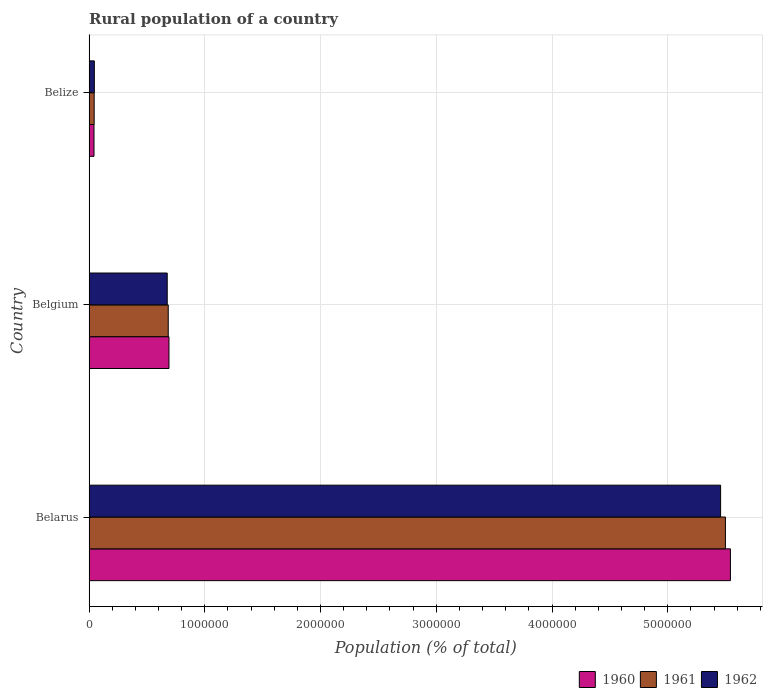How many different coloured bars are there?
Your answer should be compact. 3. Are the number of bars per tick equal to the number of legend labels?
Offer a terse response. Yes. How many bars are there on the 2nd tick from the top?
Make the answer very short. 3. What is the label of the 3rd group of bars from the top?
Give a very brief answer. Belarus. In how many cases, is the number of bars for a given country not equal to the number of legend labels?
Your response must be concise. 0. What is the rural population in 1962 in Belarus?
Your answer should be very brief. 5.46e+06. Across all countries, what is the maximum rural population in 1960?
Your answer should be compact. 5.54e+06. Across all countries, what is the minimum rural population in 1962?
Offer a very short reply. 4.54e+04. In which country was the rural population in 1961 maximum?
Offer a terse response. Belarus. In which country was the rural population in 1962 minimum?
Keep it short and to the point. Belize. What is the total rural population in 1960 in the graph?
Offer a very short reply. 6.27e+06. What is the difference between the rural population in 1961 in Belarus and that in Belgium?
Make the answer very short. 4.81e+06. What is the difference between the rural population in 1962 in Belize and the rural population in 1960 in Belgium?
Offer a terse response. -6.45e+05. What is the average rural population in 1961 per country?
Provide a short and direct response. 2.08e+06. What is the difference between the rural population in 1962 and rural population in 1961 in Belize?
Give a very brief answer. 1546. In how many countries, is the rural population in 1961 greater than 4000000 %?
Provide a short and direct response. 1. What is the ratio of the rural population in 1962 in Belarus to that in Belize?
Keep it short and to the point. 120.26. Is the rural population in 1961 in Belarus less than that in Belgium?
Offer a very short reply. No. What is the difference between the highest and the second highest rural population in 1960?
Give a very brief answer. 4.85e+06. What is the difference between the highest and the lowest rural population in 1960?
Offer a very short reply. 5.50e+06. Is the sum of the rural population in 1960 in Belarus and Belize greater than the maximum rural population in 1961 across all countries?
Ensure brevity in your answer.  Yes. What does the 2nd bar from the top in Belgium represents?
Your answer should be very brief. 1961. Is it the case that in every country, the sum of the rural population in 1961 and rural population in 1962 is greater than the rural population in 1960?
Provide a short and direct response. Yes. How many countries are there in the graph?
Your response must be concise. 3. Are the values on the major ticks of X-axis written in scientific E-notation?
Provide a succinct answer. No. Where does the legend appear in the graph?
Ensure brevity in your answer.  Bottom right. How are the legend labels stacked?
Provide a succinct answer. Horizontal. What is the title of the graph?
Keep it short and to the point. Rural population of a country. Does "2003" appear as one of the legend labels in the graph?
Provide a short and direct response. No. What is the label or title of the X-axis?
Keep it short and to the point. Population (% of total). What is the Population (% of total) in 1960 in Belarus?
Your response must be concise. 5.54e+06. What is the Population (% of total) in 1961 in Belarus?
Provide a succinct answer. 5.50e+06. What is the Population (% of total) in 1962 in Belarus?
Your response must be concise. 5.46e+06. What is the Population (% of total) in 1960 in Belgium?
Give a very brief answer. 6.90e+05. What is the Population (% of total) of 1961 in Belgium?
Offer a very short reply. 6.84e+05. What is the Population (% of total) in 1962 in Belgium?
Offer a terse response. 6.75e+05. What is the Population (% of total) in 1960 in Belize?
Provide a short and direct response. 4.23e+04. What is the Population (% of total) in 1961 in Belize?
Give a very brief answer. 4.38e+04. What is the Population (% of total) in 1962 in Belize?
Offer a terse response. 4.54e+04. Across all countries, what is the maximum Population (% of total) of 1960?
Provide a short and direct response. 5.54e+06. Across all countries, what is the maximum Population (% of total) of 1961?
Your answer should be very brief. 5.50e+06. Across all countries, what is the maximum Population (% of total) in 1962?
Offer a terse response. 5.46e+06. Across all countries, what is the minimum Population (% of total) of 1960?
Your answer should be very brief. 4.23e+04. Across all countries, what is the minimum Population (% of total) in 1961?
Your answer should be very brief. 4.38e+04. Across all countries, what is the minimum Population (% of total) of 1962?
Keep it short and to the point. 4.54e+04. What is the total Population (% of total) in 1960 in the graph?
Your response must be concise. 6.27e+06. What is the total Population (% of total) of 1961 in the graph?
Keep it short and to the point. 6.23e+06. What is the total Population (% of total) of 1962 in the graph?
Your answer should be very brief. 6.18e+06. What is the difference between the Population (% of total) in 1960 in Belarus and that in Belgium?
Your answer should be very brief. 4.85e+06. What is the difference between the Population (% of total) in 1961 in Belarus and that in Belgium?
Give a very brief answer. 4.81e+06. What is the difference between the Population (% of total) in 1962 in Belarus and that in Belgium?
Provide a short and direct response. 4.78e+06. What is the difference between the Population (% of total) in 1960 in Belarus and that in Belize?
Give a very brief answer. 5.50e+06. What is the difference between the Population (% of total) of 1961 in Belarus and that in Belize?
Keep it short and to the point. 5.45e+06. What is the difference between the Population (% of total) of 1962 in Belarus and that in Belize?
Ensure brevity in your answer.  5.41e+06. What is the difference between the Population (% of total) of 1960 in Belgium and that in Belize?
Provide a succinct answer. 6.48e+05. What is the difference between the Population (% of total) in 1961 in Belgium and that in Belize?
Your answer should be compact. 6.40e+05. What is the difference between the Population (% of total) of 1962 in Belgium and that in Belize?
Give a very brief answer. 6.30e+05. What is the difference between the Population (% of total) in 1960 in Belarus and the Population (% of total) in 1961 in Belgium?
Offer a terse response. 4.86e+06. What is the difference between the Population (% of total) in 1960 in Belarus and the Population (% of total) in 1962 in Belgium?
Provide a short and direct response. 4.87e+06. What is the difference between the Population (% of total) in 1961 in Belarus and the Population (% of total) in 1962 in Belgium?
Make the answer very short. 4.82e+06. What is the difference between the Population (% of total) in 1960 in Belarus and the Population (% of total) in 1961 in Belize?
Offer a terse response. 5.50e+06. What is the difference between the Population (% of total) in 1960 in Belarus and the Population (% of total) in 1962 in Belize?
Your answer should be compact. 5.50e+06. What is the difference between the Population (% of total) in 1961 in Belarus and the Population (% of total) in 1962 in Belize?
Offer a terse response. 5.45e+06. What is the difference between the Population (% of total) of 1960 in Belgium and the Population (% of total) of 1961 in Belize?
Ensure brevity in your answer.  6.46e+05. What is the difference between the Population (% of total) in 1960 in Belgium and the Population (% of total) in 1962 in Belize?
Provide a succinct answer. 6.45e+05. What is the difference between the Population (% of total) in 1961 in Belgium and the Population (% of total) in 1962 in Belize?
Keep it short and to the point. 6.38e+05. What is the average Population (% of total) in 1960 per country?
Ensure brevity in your answer.  2.09e+06. What is the average Population (% of total) in 1961 per country?
Your answer should be compact. 2.08e+06. What is the average Population (% of total) in 1962 per country?
Provide a succinct answer. 2.06e+06. What is the difference between the Population (% of total) of 1960 and Population (% of total) of 1961 in Belarus?
Keep it short and to the point. 4.32e+04. What is the difference between the Population (% of total) of 1960 and Population (% of total) of 1962 in Belarus?
Your response must be concise. 8.49e+04. What is the difference between the Population (% of total) in 1961 and Population (% of total) in 1962 in Belarus?
Ensure brevity in your answer.  4.16e+04. What is the difference between the Population (% of total) of 1960 and Population (% of total) of 1961 in Belgium?
Provide a succinct answer. 6336. What is the difference between the Population (% of total) of 1960 and Population (% of total) of 1962 in Belgium?
Keep it short and to the point. 1.51e+04. What is the difference between the Population (% of total) of 1961 and Population (% of total) of 1962 in Belgium?
Give a very brief answer. 8798. What is the difference between the Population (% of total) in 1960 and Population (% of total) in 1961 in Belize?
Your response must be concise. -1502. What is the difference between the Population (% of total) of 1960 and Population (% of total) of 1962 in Belize?
Provide a short and direct response. -3048. What is the difference between the Population (% of total) in 1961 and Population (% of total) in 1962 in Belize?
Offer a terse response. -1546. What is the ratio of the Population (% of total) of 1960 in Belarus to that in Belgium?
Offer a terse response. 8.03. What is the ratio of the Population (% of total) in 1961 in Belarus to that in Belgium?
Provide a succinct answer. 8.04. What is the ratio of the Population (% of total) in 1962 in Belarus to that in Belgium?
Ensure brevity in your answer.  8.08. What is the ratio of the Population (% of total) in 1960 in Belarus to that in Belize?
Your answer should be very brief. 130.93. What is the ratio of the Population (% of total) of 1961 in Belarus to that in Belize?
Give a very brief answer. 125.46. What is the ratio of the Population (% of total) in 1962 in Belarus to that in Belize?
Provide a short and direct response. 120.26. What is the ratio of the Population (% of total) of 1960 in Belgium to that in Belize?
Your response must be concise. 16.31. What is the ratio of the Population (% of total) in 1961 in Belgium to that in Belize?
Your answer should be compact. 15.6. What is the ratio of the Population (% of total) in 1962 in Belgium to that in Belize?
Provide a short and direct response. 14.88. What is the difference between the highest and the second highest Population (% of total) of 1960?
Offer a terse response. 4.85e+06. What is the difference between the highest and the second highest Population (% of total) in 1961?
Your response must be concise. 4.81e+06. What is the difference between the highest and the second highest Population (% of total) in 1962?
Keep it short and to the point. 4.78e+06. What is the difference between the highest and the lowest Population (% of total) in 1960?
Offer a terse response. 5.50e+06. What is the difference between the highest and the lowest Population (% of total) in 1961?
Offer a very short reply. 5.45e+06. What is the difference between the highest and the lowest Population (% of total) of 1962?
Make the answer very short. 5.41e+06. 